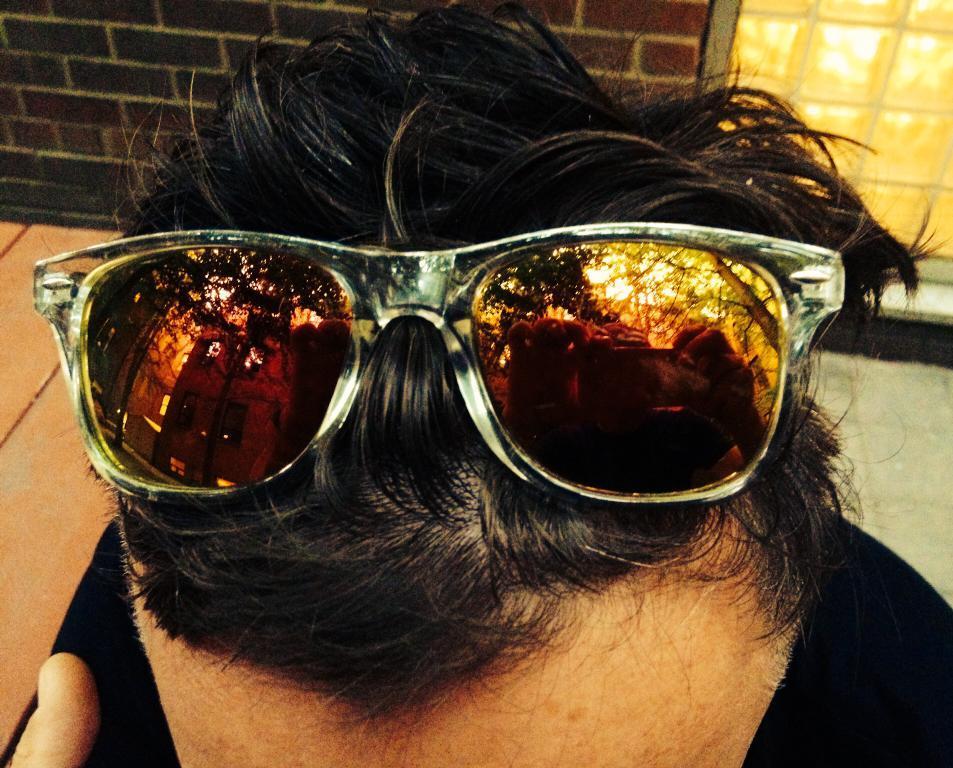Can you describe this image briefly? In the image there are goggles on the the hair of a person and behind the person there is a brick wall and a window. 